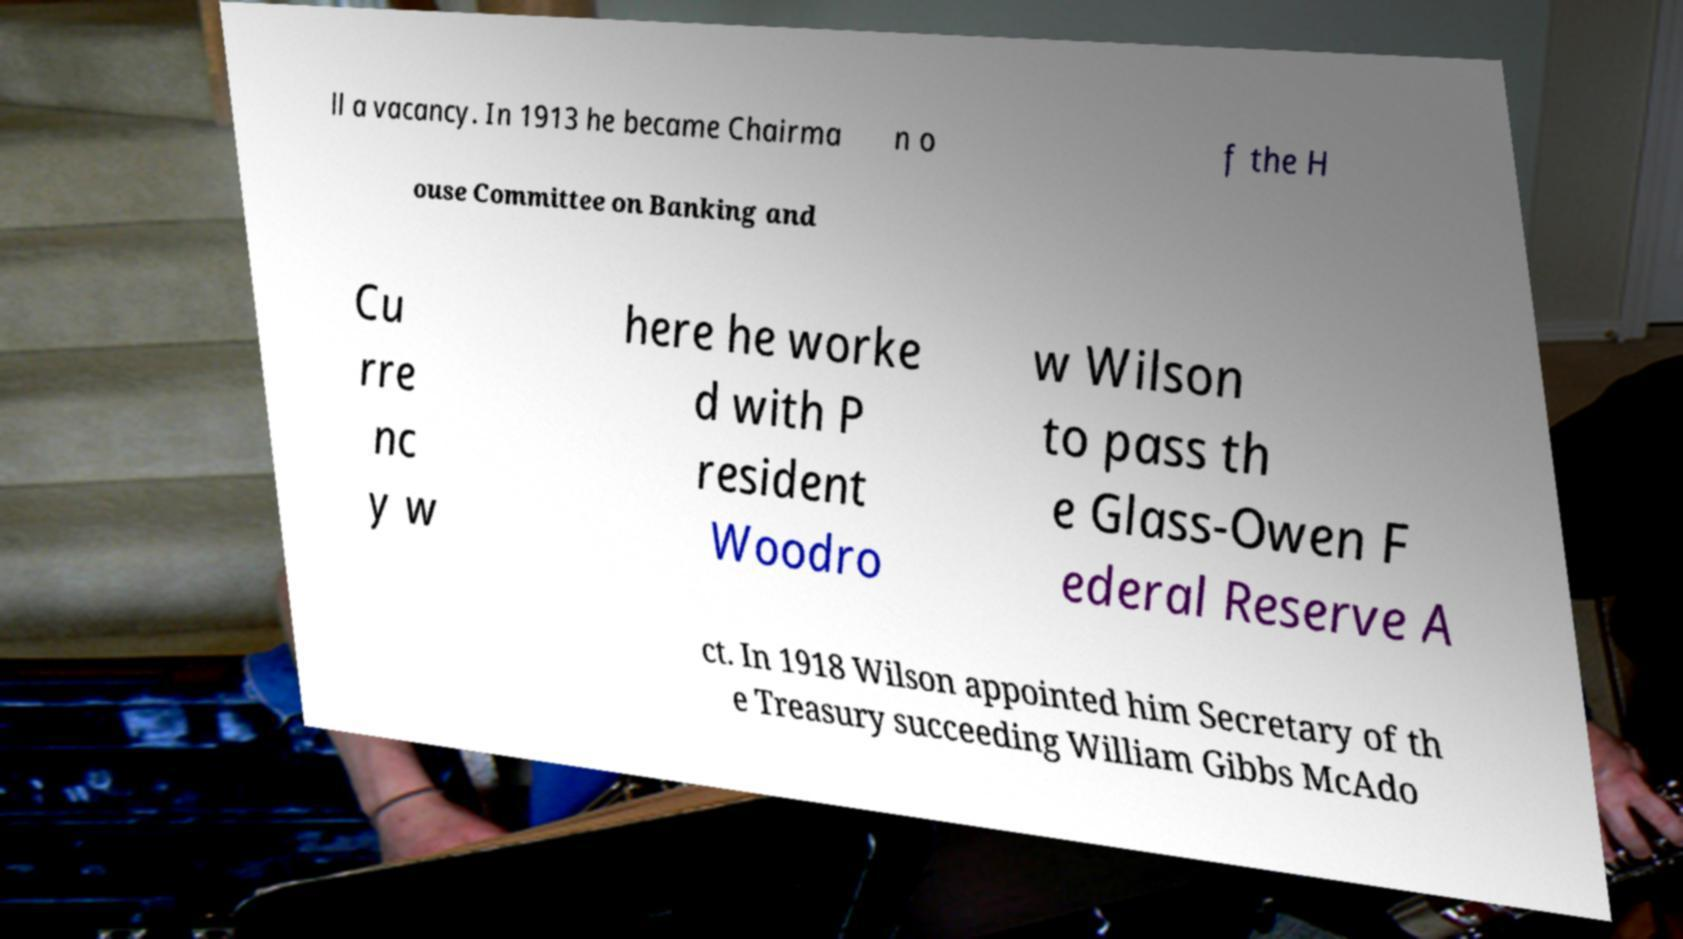Can you read and provide the text displayed in the image?This photo seems to have some interesting text. Can you extract and type it out for me? ll a vacancy. In 1913 he became Chairma n o f the H ouse Committee on Banking and Cu rre nc y w here he worke d with P resident Woodro w Wilson to pass th e Glass-Owen F ederal Reserve A ct. In 1918 Wilson appointed him Secretary of th e Treasury succeeding William Gibbs McAdo 